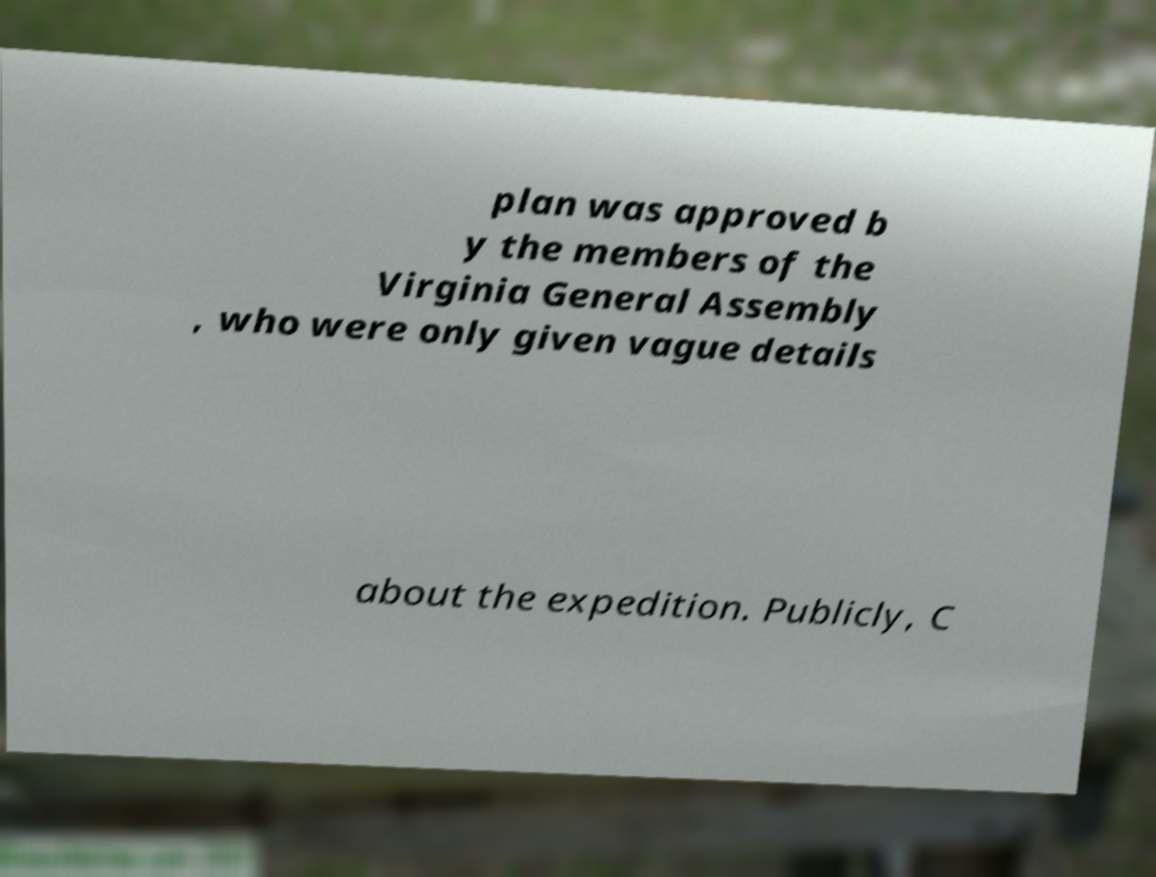There's text embedded in this image that I need extracted. Can you transcribe it verbatim? plan was approved b y the members of the Virginia General Assembly , who were only given vague details about the expedition. Publicly, C 